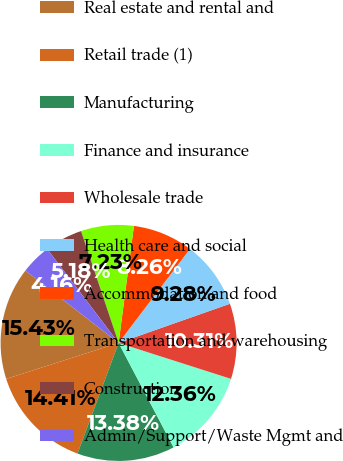Convert chart to OTSL. <chart><loc_0><loc_0><loc_500><loc_500><pie_chart><fcel>Real estate and rental and<fcel>Retail trade (1)<fcel>Manufacturing<fcel>Finance and insurance<fcel>Wholesale trade<fcel>Health care and social<fcel>Accommodation and food<fcel>Transportation and warehousing<fcel>Construction<fcel>Admin/Support/Waste Mgmt and<nl><fcel>15.43%<fcel>14.41%<fcel>13.38%<fcel>12.36%<fcel>10.31%<fcel>9.28%<fcel>8.26%<fcel>7.23%<fcel>5.18%<fcel>4.16%<nl></chart> 